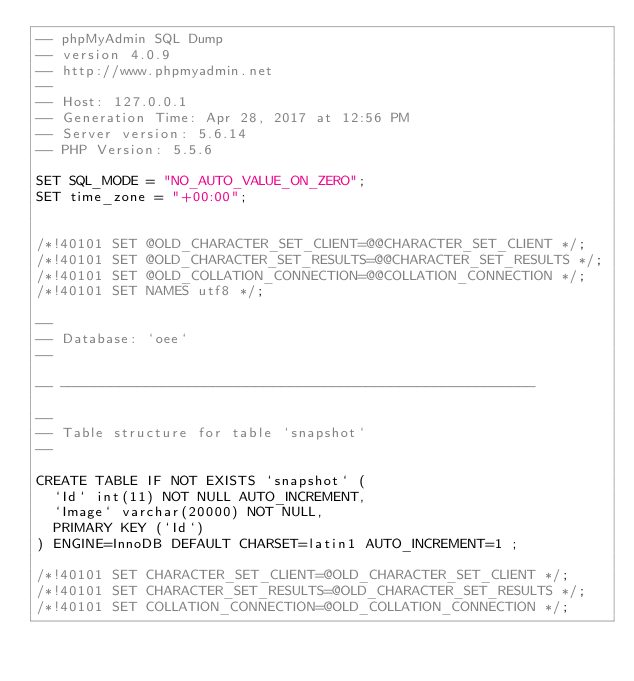Convert code to text. <code><loc_0><loc_0><loc_500><loc_500><_SQL_>-- phpMyAdmin SQL Dump
-- version 4.0.9
-- http://www.phpmyadmin.net
--
-- Host: 127.0.0.1
-- Generation Time: Apr 28, 2017 at 12:56 PM
-- Server version: 5.6.14
-- PHP Version: 5.5.6

SET SQL_MODE = "NO_AUTO_VALUE_ON_ZERO";
SET time_zone = "+00:00";


/*!40101 SET @OLD_CHARACTER_SET_CLIENT=@@CHARACTER_SET_CLIENT */;
/*!40101 SET @OLD_CHARACTER_SET_RESULTS=@@CHARACTER_SET_RESULTS */;
/*!40101 SET @OLD_COLLATION_CONNECTION=@@COLLATION_CONNECTION */;
/*!40101 SET NAMES utf8 */;

--
-- Database: `oee`
--

-- --------------------------------------------------------

--
-- Table structure for table `snapshot`
--

CREATE TABLE IF NOT EXISTS `snapshot` (
  `Id` int(11) NOT NULL AUTO_INCREMENT,
  `Image` varchar(20000) NOT NULL,
  PRIMARY KEY (`Id`)
) ENGINE=InnoDB DEFAULT CHARSET=latin1 AUTO_INCREMENT=1 ;

/*!40101 SET CHARACTER_SET_CLIENT=@OLD_CHARACTER_SET_CLIENT */;
/*!40101 SET CHARACTER_SET_RESULTS=@OLD_CHARACTER_SET_RESULTS */;
/*!40101 SET COLLATION_CONNECTION=@OLD_COLLATION_CONNECTION */;
</code> 